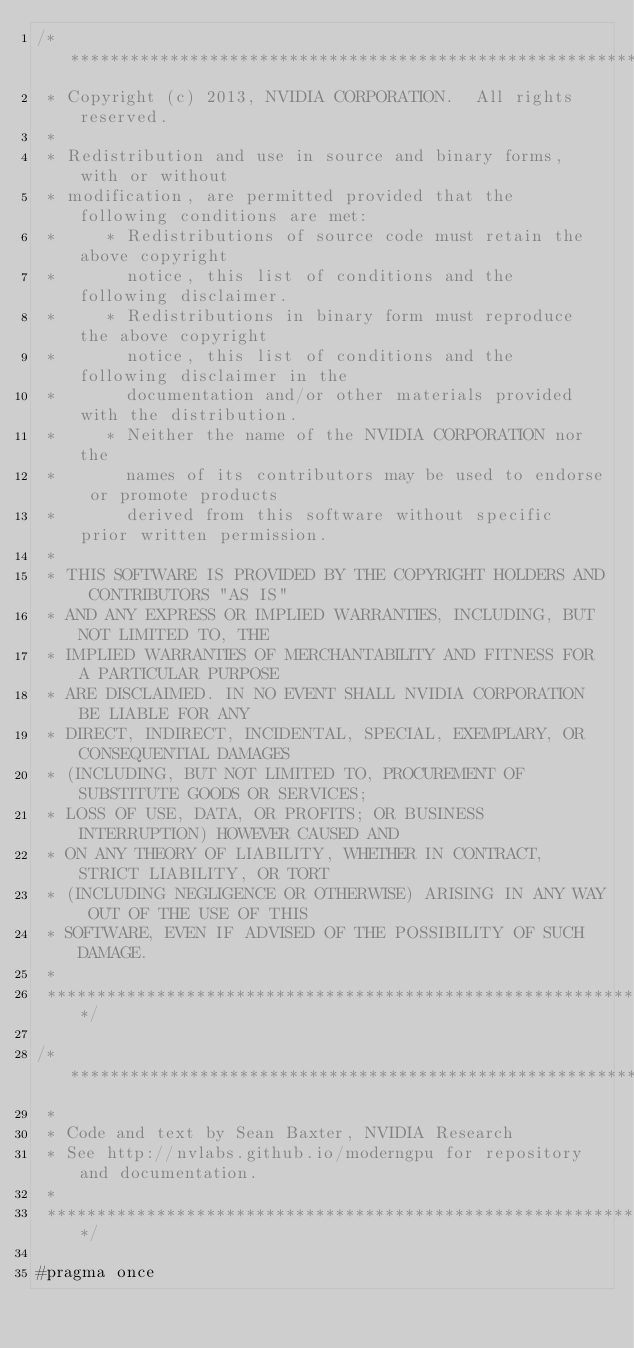Convert code to text. <code><loc_0><loc_0><loc_500><loc_500><_Cuda_>/******************************************************************************
 * Copyright (c) 2013, NVIDIA CORPORATION.  All rights reserved.
 * 
 * Redistribution and use in source and binary forms, with or without
 * modification, are permitted provided that the following conditions are met:
 *     * Redistributions of source code must retain the above copyright
 *       notice, this list of conditions and the following disclaimer.
 *     * Redistributions in binary form must reproduce the above copyright
 *       notice, this list of conditions and the following disclaimer in the
 *       documentation and/or other materials provided with the distribution.
 *     * Neither the name of the NVIDIA CORPORATION nor the
 *       names of its contributors may be used to endorse or promote products
 *       derived from this software without specific prior written permission.
 * 
 * THIS SOFTWARE IS PROVIDED BY THE COPYRIGHT HOLDERS AND CONTRIBUTORS "AS IS" 
 * AND ANY EXPRESS OR IMPLIED WARRANTIES, INCLUDING, BUT NOT LIMITED TO, THE
 * IMPLIED WARRANTIES OF MERCHANTABILITY AND FITNESS FOR A PARTICULAR PURPOSE 
 * ARE DISCLAIMED. IN NO EVENT SHALL NVIDIA CORPORATION BE LIABLE FOR ANY
 * DIRECT, INDIRECT, INCIDENTAL, SPECIAL, EXEMPLARY, OR CONSEQUENTIAL DAMAGES
 * (INCLUDING, BUT NOT LIMITED TO, PROCUREMENT OF SUBSTITUTE GOODS OR SERVICES;
 * LOSS OF USE, DATA, OR PROFITS; OR BUSINESS INTERRUPTION) HOWEVER CAUSED AND
 * ON ANY THEORY OF LIABILITY, WHETHER IN CONTRACT, STRICT LIABILITY, OR TORT
 * (INCLUDING NEGLIGENCE OR OTHERWISE) ARISING IN ANY WAY OUT OF THE USE OF THIS
 * SOFTWARE, EVEN IF ADVISED OF THE POSSIBILITY OF SUCH DAMAGE.
 *
 ******************************************************************************/

/******************************************************************************
 *
 * Code and text by Sean Baxter, NVIDIA Research
 * See http://nvlabs.github.io/moderngpu for repository and documentation.
 *
 ******************************************************************************/

#pragma once
</code> 